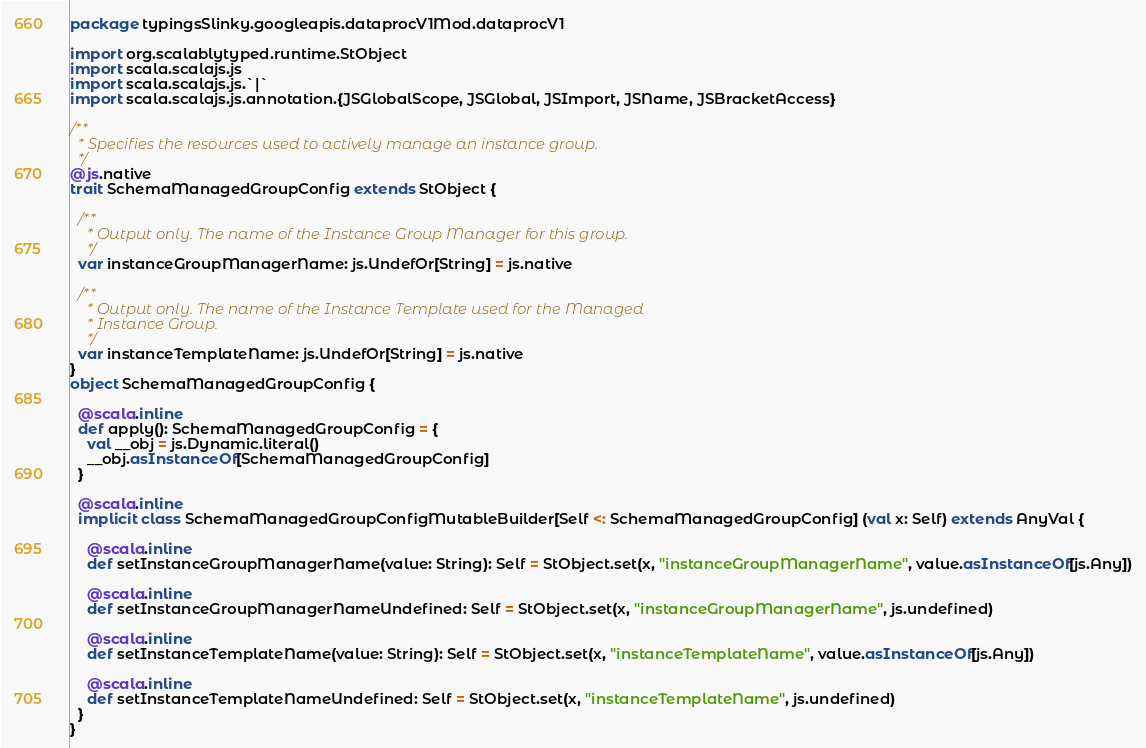<code> <loc_0><loc_0><loc_500><loc_500><_Scala_>package typingsSlinky.googleapis.dataprocV1Mod.dataprocV1

import org.scalablytyped.runtime.StObject
import scala.scalajs.js
import scala.scalajs.js.`|`
import scala.scalajs.js.annotation.{JSGlobalScope, JSGlobal, JSImport, JSName, JSBracketAccess}

/**
  * Specifies the resources used to actively manage an instance group.
  */
@js.native
trait SchemaManagedGroupConfig extends StObject {
  
  /**
    * Output only. The name of the Instance Group Manager for this group.
    */
  var instanceGroupManagerName: js.UndefOr[String] = js.native
  
  /**
    * Output only. The name of the Instance Template used for the Managed
    * Instance Group.
    */
  var instanceTemplateName: js.UndefOr[String] = js.native
}
object SchemaManagedGroupConfig {
  
  @scala.inline
  def apply(): SchemaManagedGroupConfig = {
    val __obj = js.Dynamic.literal()
    __obj.asInstanceOf[SchemaManagedGroupConfig]
  }
  
  @scala.inline
  implicit class SchemaManagedGroupConfigMutableBuilder[Self <: SchemaManagedGroupConfig] (val x: Self) extends AnyVal {
    
    @scala.inline
    def setInstanceGroupManagerName(value: String): Self = StObject.set(x, "instanceGroupManagerName", value.asInstanceOf[js.Any])
    
    @scala.inline
    def setInstanceGroupManagerNameUndefined: Self = StObject.set(x, "instanceGroupManagerName", js.undefined)
    
    @scala.inline
    def setInstanceTemplateName(value: String): Self = StObject.set(x, "instanceTemplateName", value.asInstanceOf[js.Any])
    
    @scala.inline
    def setInstanceTemplateNameUndefined: Self = StObject.set(x, "instanceTemplateName", js.undefined)
  }
}
</code> 